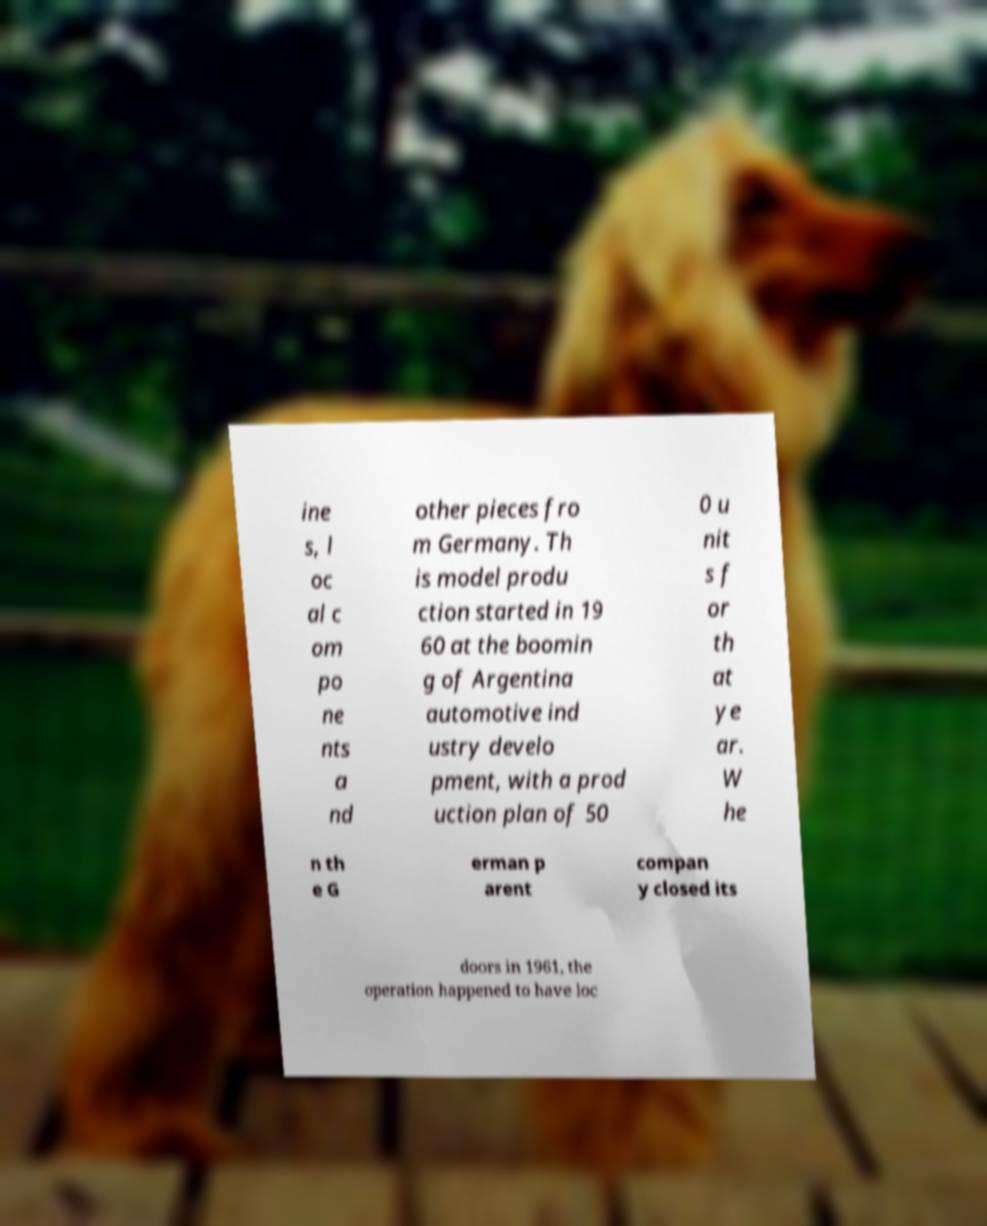Please read and relay the text visible in this image. What does it say? ine s, l oc al c om po ne nts a nd other pieces fro m Germany. Th is model produ ction started in 19 60 at the boomin g of Argentina automotive ind ustry develo pment, with a prod uction plan of 50 0 u nit s f or th at ye ar. W he n th e G erman p arent compan y closed its doors in 1961, the operation happened to have loc 